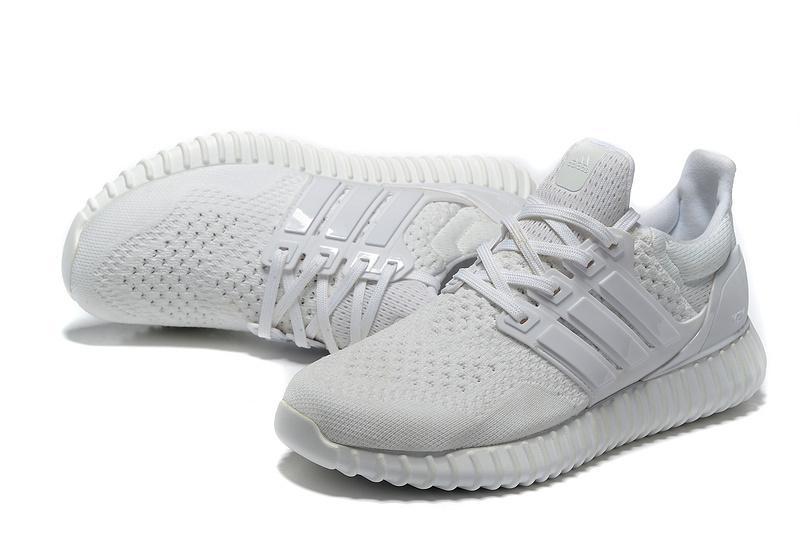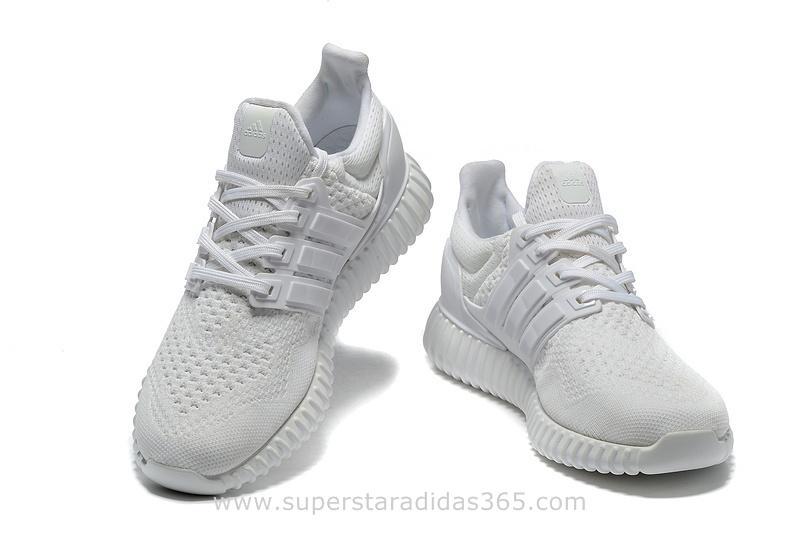The first image is the image on the left, the second image is the image on the right. Analyze the images presented: Is the assertion "In at least one image, white shoes have vertical ridges around the entire bottom of the shoe." valid? Answer yes or no. Yes. 